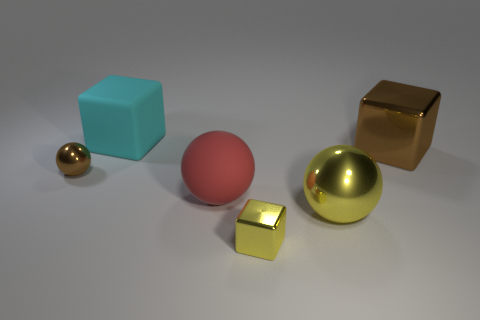Add 1 matte objects. How many objects exist? 7 Subtract 0 gray spheres. How many objects are left? 6 Subtract all brown metal objects. Subtract all big purple matte spheres. How many objects are left? 4 Add 1 cyan rubber things. How many cyan rubber things are left? 2 Add 3 cyan blocks. How many cyan blocks exist? 4 